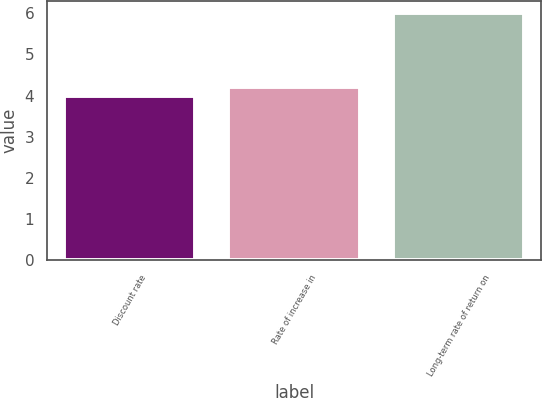Convert chart. <chart><loc_0><loc_0><loc_500><loc_500><bar_chart><fcel>Discount rate<fcel>Rate of increase in<fcel>Long-term rate of return on<nl><fcel>4<fcel>4.2<fcel>6<nl></chart> 